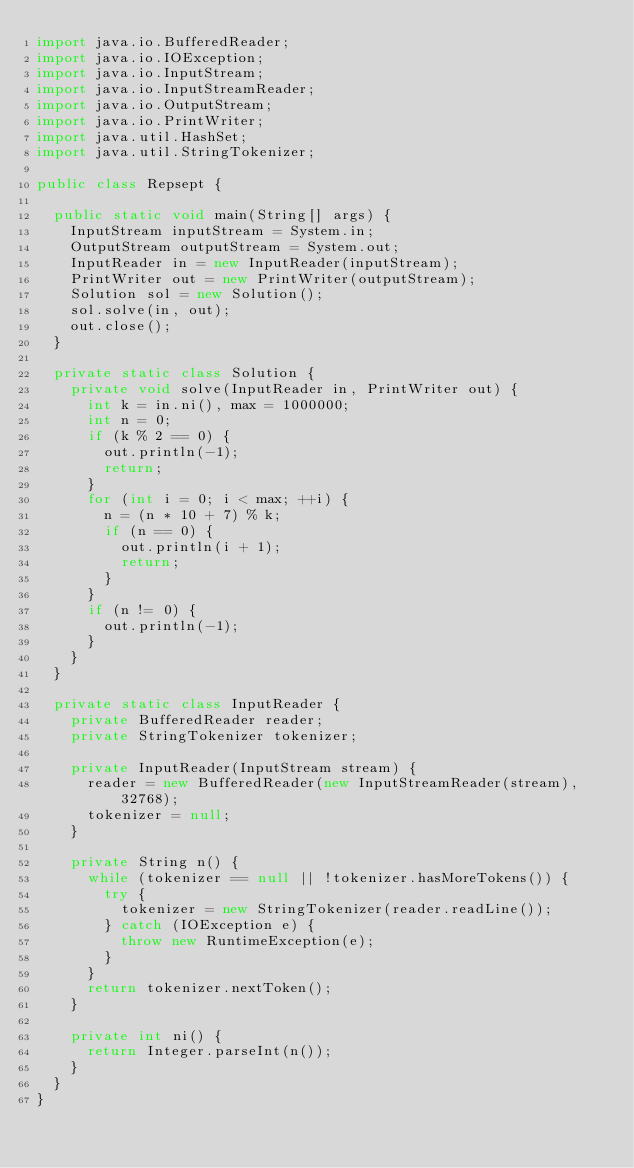<code> <loc_0><loc_0><loc_500><loc_500><_Java_>import java.io.BufferedReader;
import java.io.IOException;
import java.io.InputStream;
import java.io.InputStreamReader;
import java.io.OutputStream;
import java.io.PrintWriter;
import java.util.HashSet;
import java.util.StringTokenizer;

public class Repsept {

	public static void main(String[] args) {
		InputStream inputStream = System.in;
		OutputStream outputStream = System.out;
		InputReader in = new InputReader(inputStream);
		PrintWriter out = new PrintWriter(outputStream);
		Solution sol = new Solution();
		sol.solve(in, out);
		out.close();
	}

	private static class Solution {
		private void solve(InputReader in, PrintWriter out) {
			int k = in.ni(), max = 1000000;
			int n = 0;
			if (k % 2 == 0) {
				out.println(-1);
				return;
			}
			for (int i = 0; i < max; ++i) {
				n = (n * 10 + 7) % k;
				if (n == 0) {
					out.println(i + 1);
					return;
				}
			}
			if (n != 0) {
				out.println(-1);
			}
		}
	}

	private static class InputReader {
		private BufferedReader reader;
		private StringTokenizer tokenizer;

		private InputReader(InputStream stream) {
			reader = new BufferedReader(new InputStreamReader(stream), 32768);
			tokenizer = null;
		}

		private String n() {
			while (tokenizer == null || !tokenizer.hasMoreTokens()) {
				try {
					tokenizer = new StringTokenizer(reader.readLine());
				} catch (IOException e) {
					throw new RuntimeException(e);
				}
			}
			return tokenizer.nextToken();
		}

		private int ni() {
			return Integer.parseInt(n());
		}
	}
}</code> 